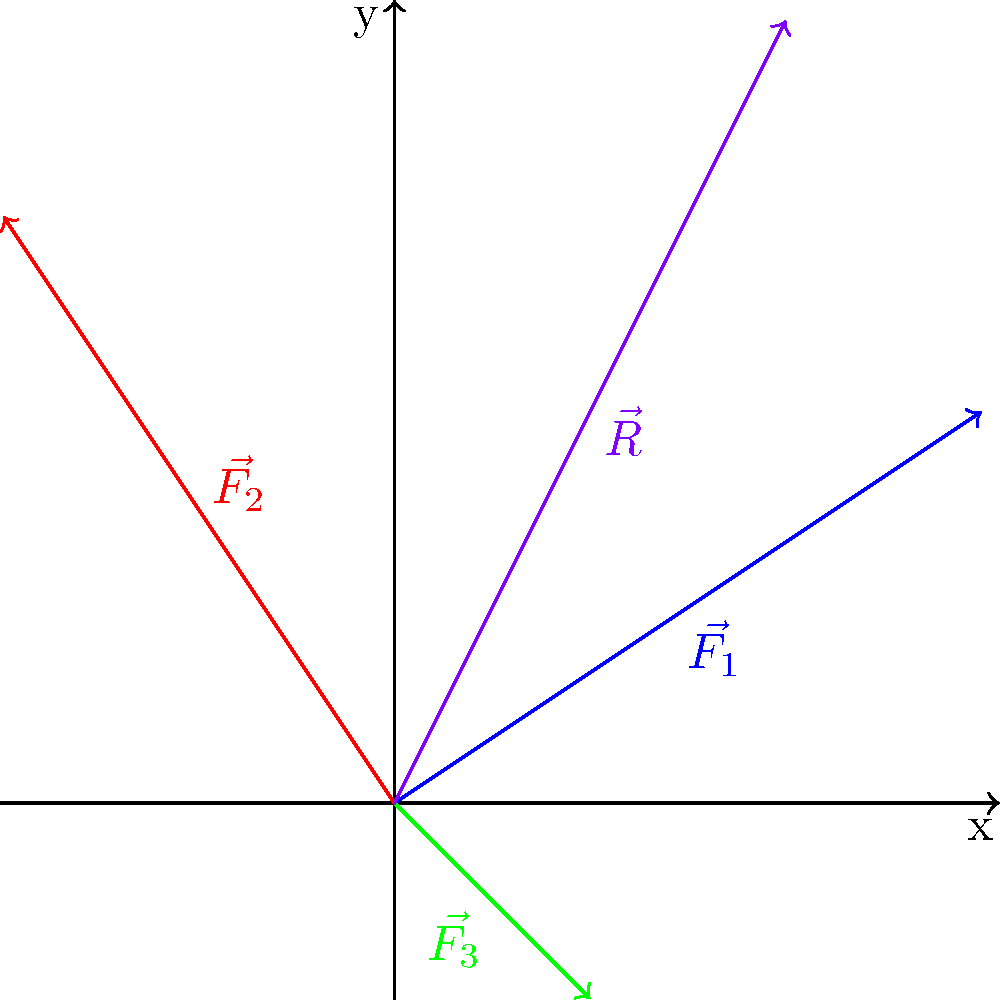As a retired MCU actor, imagine you're helping design a new superhero for an upcoming film. The special effects team needs to calculate the resultant force acting on the hero during a complex action sequence. Three force vectors are acting on the hero simultaneously: $\vec{F_1} = (3,2)$ N, $\vec{F_2} = (-2,3)$ N, and $\vec{F_3} = (1,-1)$ N. What is the magnitude of the resultant force vector $\vec{R}$ acting on the superhero, rounded to two decimal places? To find the magnitude of the resultant force vector, we need to follow these steps:

1) First, we need to find the resultant vector $\vec{R}$ by adding the three force vectors:
   $\vec{R} = \vec{F_1} + \vec{F_2} + \vec{F_3}$

2) Let's add the x and y components separately:
   $R_x = 3 + (-2) + 1 = 2$ N
   $R_y = 2 + 3 + (-1) = 4$ N

3) So, the resultant vector is $\vec{R} = (2,4)$ N

4) To find the magnitude of $\vec{R}$, we use the Pythagorean theorem:
   $|\vec{R}| = \sqrt{R_x^2 + R_y^2}$

5) Substituting the values:
   $|\vec{R}| = \sqrt{2^2 + 4^2}$

6) Simplifying:
   $|\vec{R}| = \sqrt{4 + 16} = \sqrt{20}$

7) Calculating and rounding to two decimal places:
   $|\vec{R}| \approx 4.47$ N

Therefore, the magnitude of the resultant force vector acting on the superhero is approximately 4.47 N.
Answer: 4.47 N 